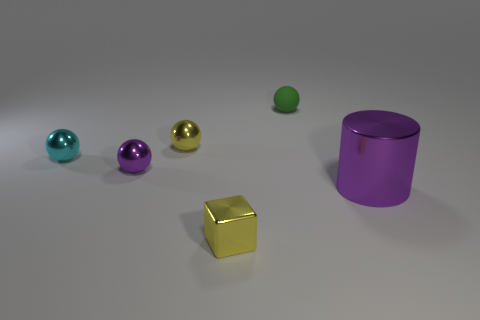Is there anything else that is the same size as the purple cylinder?
Ensure brevity in your answer.  No. There is a sphere that is to the right of the small yellow thing that is in front of the small cyan metallic ball; what color is it?
Provide a short and direct response. Green. There is a yellow shiny object that is behind the small yellow metal block in front of the small yellow metallic object to the left of the yellow cube; what shape is it?
Keep it short and to the point. Sphere. How many other big cylinders are made of the same material as the large purple cylinder?
Your response must be concise. 0. What number of yellow shiny spheres are in front of the big purple metal thing right of the rubber object?
Ensure brevity in your answer.  0. What number of blue rubber objects are there?
Provide a short and direct response. 0. Does the small cyan ball have the same material as the purple object that is behind the large purple thing?
Ensure brevity in your answer.  Yes. There is a metal ball on the right side of the tiny purple metal thing; does it have the same color as the metal block?
Your response must be concise. Yes. There is a thing that is both in front of the tiny purple object and to the left of the large thing; what is its material?
Ensure brevity in your answer.  Metal. The purple cylinder is what size?
Your response must be concise. Large. 